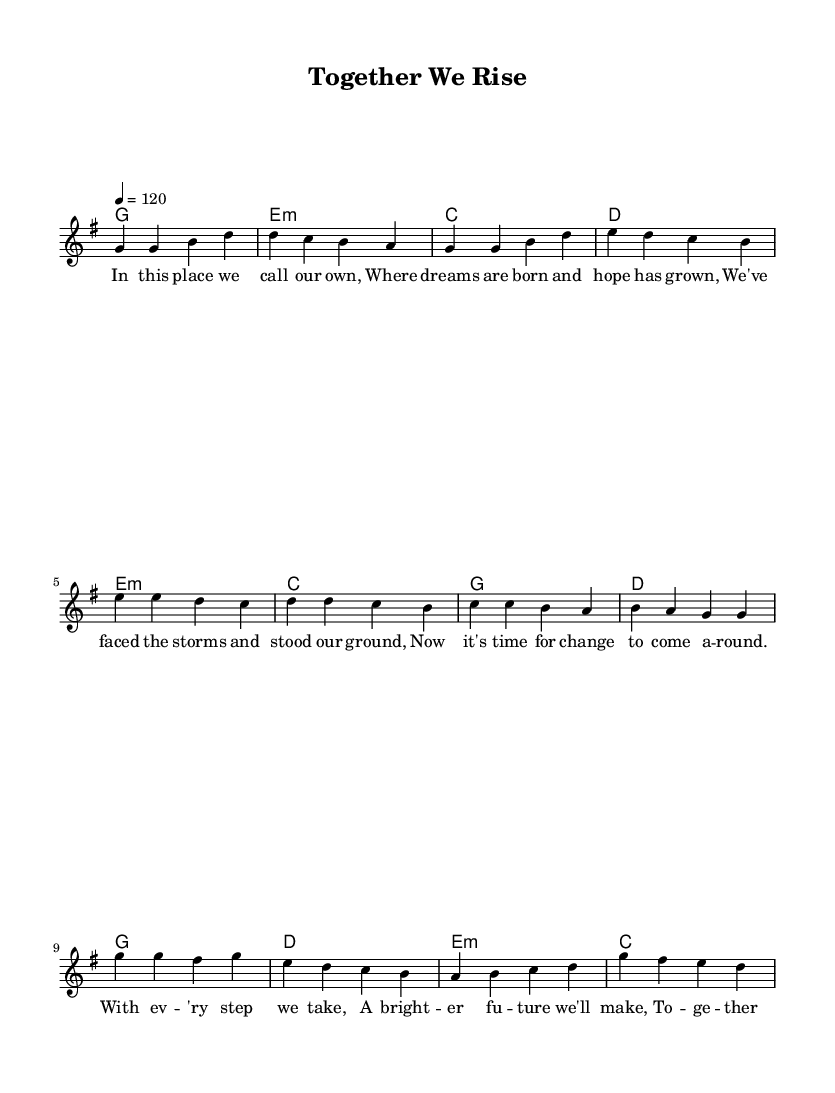What is the key signature of this music? The key signature is indicated by the sharp or flat symbols at the beginning of the staff. In this case, there are no sharps or flats, which indicates that it is in G major.
Answer: G major What is the time signature of this piece? The time signature is represented as a fraction at the beginning of the staff. Here, it is 4 over 4, meaning there are four beats in each measure and the quarter note gets one beat.
Answer: 4/4 What is the tempo marking for this music? The tempo is provided in beats per minute, shown beneath the tempo marking. Here, it indicates that the piece should be played at a speed of 120 beats per minute.
Answer: 120 How many measures are in the verse section? The verse section consists of the phrases defined in the melody part. By counting each set of bars corresponding to the verse lyrics, we find there are four measures.
Answer: 4 What is the first chord played in the song? The first chord in the harmonies section corresponds to the first melody note. It begins with the G major chord on the first measure, as indicated in the chord mode.
Answer: G What is the overall theme of the lyrics in this piece? By analyzing the lyrics presented, they revolve around hope, community spirit, and collective progress, emphasizing unity and standing together during challenging times.
Answer: Unity What type of song structure is used in this anthem? The song follows a common pop structure which involves verses, a pre-chorus, and a chorus, allowing for a build-up of emotion and engagement throughout the piece.
Answer: Verse-pre-chorus-chorus 